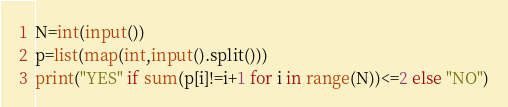Convert code to text. <code><loc_0><loc_0><loc_500><loc_500><_Python_>N=int(input())
p=list(map(int,input().split()))
print("YES" if sum(p[i]!=i+1 for i in range(N))<=2 else "NO")</code> 